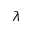<formula> <loc_0><loc_0><loc_500><loc_500>\lambda</formula> 